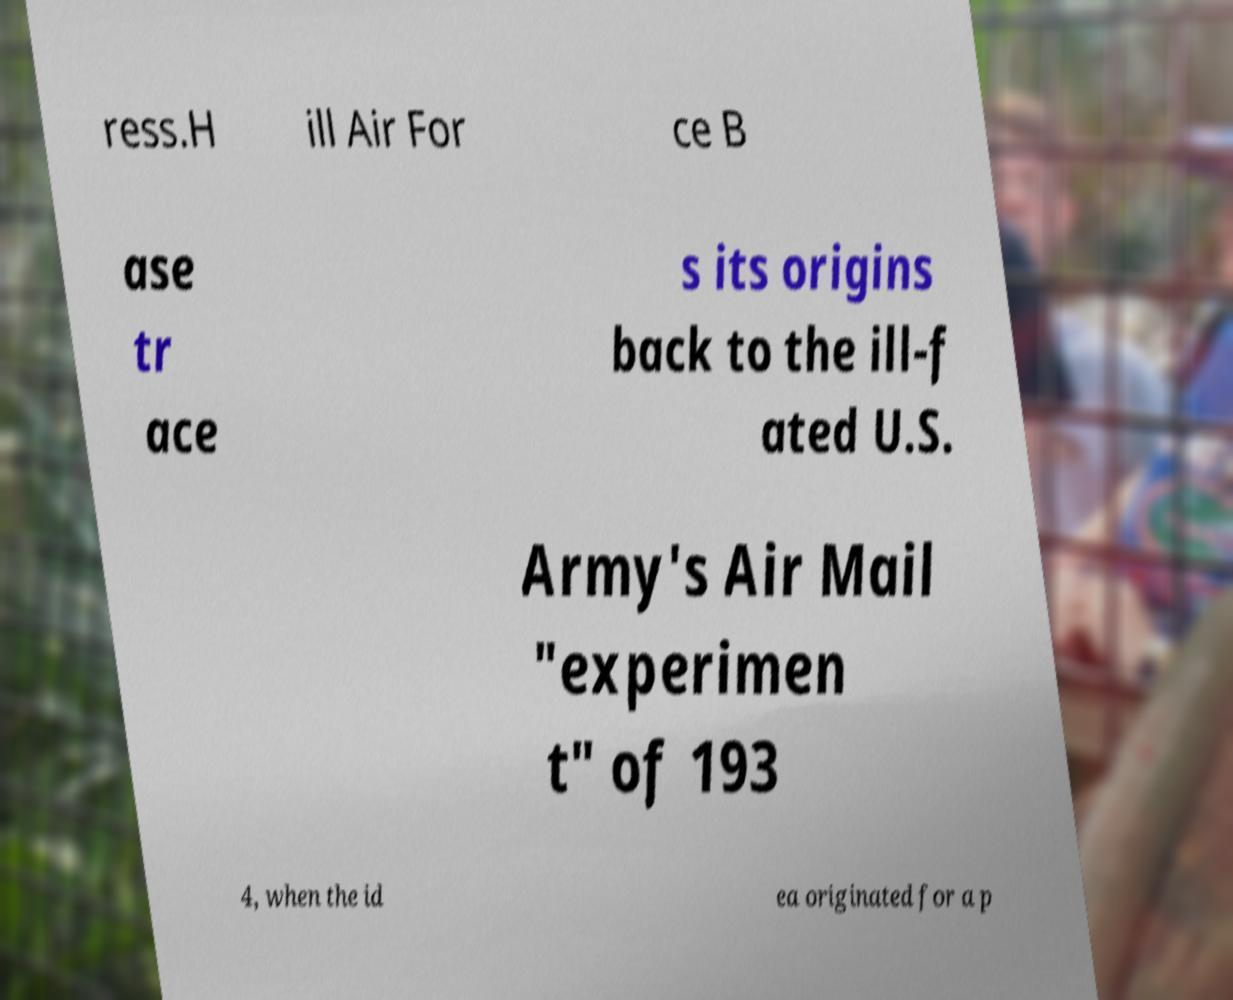I need the written content from this picture converted into text. Can you do that? ress.H ill Air For ce B ase tr ace s its origins back to the ill-f ated U.S. Army's Air Mail "experimen t" of 193 4, when the id ea originated for a p 